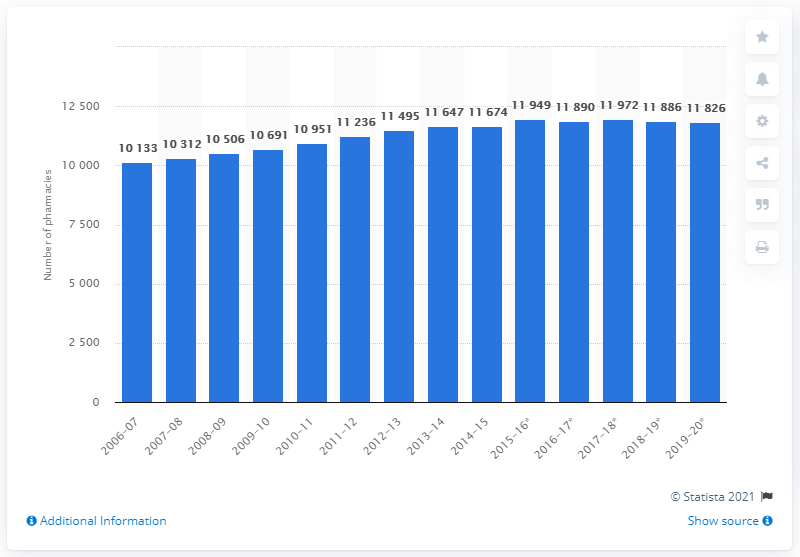Draw attention to some important aspects in this diagram. There were 11,886 pharmacies in England in the year 2017/2018. 